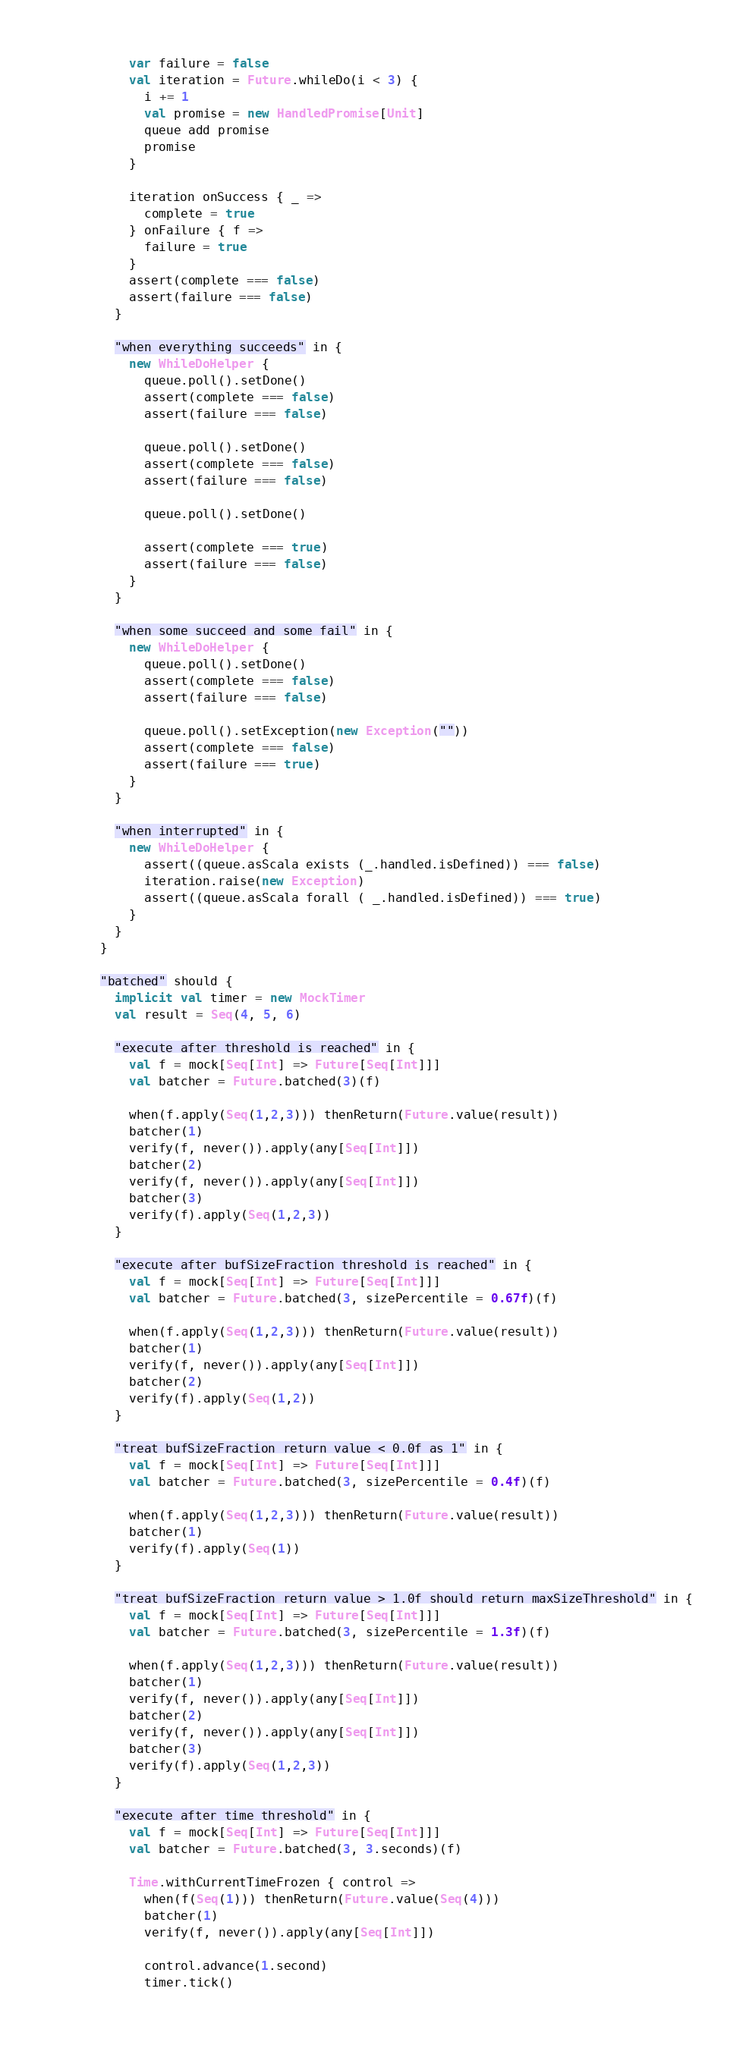Convert code to text. <code><loc_0><loc_0><loc_500><loc_500><_Scala_>          var failure = false
          val iteration = Future.whileDo(i < 3) {
            i += 1
            val promise = new HandledPromise[Unit]
            queue add promise
            promise
          }

          iteration onSuccess { _ =>
            complete = true
          } onFailure { f =>
            failure = true
          }
          assert(complete === false)
          assert(failure === false)
        }

        "when everything succeeds" in {
          new WhileDoHelper {
            queue.poll().setDone()
            assert(complete === false)
            assert(failure === false)

            queue.poll().setDone()
            assert(complete === false)
            assert(failure === false)

            queue.poll().setDone()

            assert(complete === true)
            assert(failure === false)
          }
        }

        "when some succeed and some fail" in {
          new WhileDoHelper {
            queue.poll().setDone()
            assert(complete === false)
            assert(failure === false)

            queue.poll().setException(new Exception(""))
            assert(complete === false)
            assert(failure === true)
          }
        }

        "when interrupted" in {
          new WhileDoHelper {
            assert((queue.asScala exists (_.handled.isDefined)) === false)
            iteration.raise(new Exception)
            assert((queue.asScala forall ( _.handled.isDefined)) === true)
          }
        }
      }

      "batched" should {
        implicit val timer = new MockTimer
        val result = Seq(4, 5, 6)

        "execute after threshold is reached" in {
          val f = mock[Seq[Int] => Future[Seq[Int]]]
          val batcher = Future.batched(3)(f)

          when(f.apply(Seq(1,2,3))) thenReturn(Future.value(result))
          batcher(1)
          verify(f, never()).apply(any[Seq[Int]])
          batcher(2)
          verify(f, never()).apply(any[Seq[Int]])
          batcher(3)
          verify(f).apply(Seq(1,2,3))
        }

        "execute after bufSizeFraction threshold is reached" in {
          val f = mock[Seq[Int] => Future[Seq[Int]]]
          val batcher = Future.batched(3, sizePercentile = 0.67f)(f)

          when(f.apply(Seq(1,2,3))) thenReturn(Future.value(result))
          batcher(1)
          verify(f, never()).apply(any[Seq[Int]])
          batcher(2)
          verify(f).apply(Seq(1,2))
        }

        "treat bufSizeFraction return value < 0.0f as 1" in {
          val f = mock[Seq[Int] => Future[Seq[Int]]]
          val batcher = Future.batched(3, sizePercentile = 0.4f)(f)

          when(f.apply(Seq(1,2,3))) thenReturn(Future.value(result))
          batcher(1)
          verify(f).apply(Seq(1))
        }

        "treat bufSizeFraction return value > 1.0f should return maxSizeThreshold" in {
          val f = mock[Seq[Int] => Future[Seq[Int]]]
          val batcher = Future.batched(3, sizePercentile = 1.3f)(f)

          when(f.apply(Seq(1,2,3))) thenReturn(Future.value(result))
          batcher(1)
          verify(f, never()).apply(any[Seq[Int]])
          batcher(2)
          verify(f, never()).apply(any[Seq[Int]])
          batcher(3)
          verify(f).apply(Seq(1,2,3))
        }

        "execute after time threshold" in {
          val f = mock[Seq[Int] => Future[Seq[Int]]]
          val batcher = Future.batched(3, 3.seconds)(f)

          Time.withCurrentTimeFrozen { control =>
            when(f(Seq(1))) thenReturn(Future.value(Seq(4)))
            batcher(1)
            verify(f, never()).apply(any[Seq[Int]])

            control.advance(1.second)
            timer.tick()</code> 